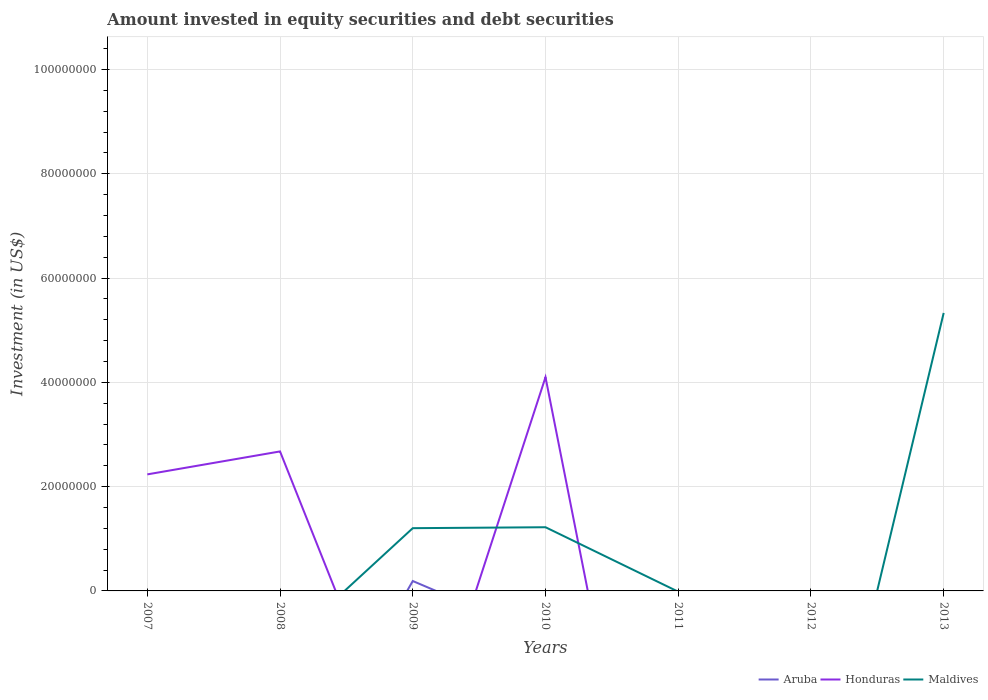How many different coloured lines are there?
Give a very brief answer. 3. Across all years, what is the maximum amount invested in equity securities and debt securities in Aruba?
Your response must be concise. 0. What is the difference between the highest and the second highest amount invested in equity securities and debt securities in Aruba?
Your answer should be compact. 1.90e+06. Are the values on the major ticks of Y-axis written in scientific E-notation?
Give a very brief answer. No. Does the graph contain grids?
Ensure brevity in your answer.  Yes. How many legend labels are there?
Your answer should be very brief. 3. What is the title of the graph?
Make the answer very short. Amount invested in equity securities and debt securities. Does "Bangladesh" appear as one of the legend labels in the graph?
Provide a succinct answer. No. What is the label or title of the Y-axis?
Offer a terse response. Investment (in US$). What is the Investment (in US$) of Aruba in 2007?
Offer a terse response. 0. What is the Investment (in US$) of Honduras in 2007?
Ensure brevity in your answer.  2.24e+07. What is the Investment (in US$) of Maldives in 2007?
Keep it short and to the point. 0. What is the Investment (in US$) of Honduras in 2008?
Your answer should be compact. 2.68e+07. What is the Investment (in US$) of Aruba in 2009?
Your response must be concise. 1.90e+06. What is the Investment (in US$) in Honduras in 2009?
Your answer should be compact. 0. What is the Investment (in US$) in Maldives in 2009?
Provide a short and direct response. 1.20e+07. What is the Investment (in US$) of Aruba in 2010?
Your answer should be very brief. 0. What is the Investment (in US$) of Honduras in 2010?
Make the answer very short. 4.10e+07. What is the Investment (in US$) in Maldives in 2010?
Ensure brevity in your answer.  1.22e+07. What is the Investment (in US$) of Aruba in 2012?
Keep it short and to the point. 0. What is the Investment (in US$) of Honduras in 2012?
Give a very brief answer. 0. What is the Investment (in US$) in Honduras in 2013?
Ensure brevity in your answer.  0. What is the Investment (in US$) of Maldives in 2013?
Provide a succinct answer. 5.33e+07. Across all years, what is the maximum Investment (in US$) in Aruba?
Your answer should be very brief. 1.90e+06. Across all years, what is the maximum Investment (in US$) in Honduras?
Offer a terse response. 4.10e+07. Across all years, what is the maximum Investment (in US$) in Maldives?
Ensure brevity in your answer.  5.33e+07. Across all years, what is the minimum Investment (in US$) in Maldives?
Your answer should be very brief. 0. What is the total Investment (in US$) of Aruba in the graph?
Provide a succinct answer. 1.90e+06. What is the total Investment (in US$) of Honduras in the graph?
Give a very brief answer. 9.01e+07. What is the total Investment (in US$) of Maldives in the graph?
Provide a succinct answer. 7.76e+07. What is the difference between the Investment (in US$) in Honduras in 2007 and that in 2008?
Provide a succinct answer. -4.40e+06. What is the difference between the Investment (in US$) in Honduras in 2007 and that in 2010?
Give a very brief answer. -1.86e+07. What is the difference between the Investment (in US$) in Honduras in 2008 and that in 2010?
Offer a terse response. -1.42e+07. What is the difference between the Investment (in US$) of Maldives in 2009 and that in 2010?
Offer a terse response. -1.81e+05. What is the difference between the Investment (in US$) of Maldives in 2009 and that in 2013?
Provide a short and direct response. -4.13e+07. What is the difference between the Investment (in US$) of Maldives in 2010 and that in 2013?
Your response must be concise. -4.11e+07. What is the difference between the Investment (in US$) in Honduras in 2007 and the Investment (in US$) in Maldives in 2009?
Offer a very short reply. 1.03e+07. What is the difference between the Investment (in US$) in Honduras in 2007 and the Investment (in US$) in Maldives in 2010?
Offer a terse response. 1.01e+07. What is the difference between the Investment (in US$) of Honduras in 2007 and the Investment (in US$) of Maldives in 2013?
Provide a succinct answer. -3.10e+07. What is the difference between the Investment (in US$) in Honduras in 2008 and the Investment (in US$) in Maldives in 2009?
Keep it short and to the point. 1.47e+07. What is the difference between the Investment (in US$) in Honduras in 2008 and the Investment (in US$) in Maldives in 2010?
Give a very brief answer. 1.45e+07. What is the difference between the Investment (in US$) in Honduras in 2008 and the Investment (in US$) in Maldives in 2013?
Ensure brevity in your answer.  -2.66e+07. What is the difference between the Investment (in US$) of Aruba in 2009 and the Investment (in US$) of Honduras in 2010?
Give a very brief answer. -3.91e+07. What is the difference between the Investment (in US$) of Aruba in 2009 and the Investment (in US$) of Maldives in 2010?
Ensure brevity in your answer.  -1.03e+07. What is the difference between the Investment (in US$) of Aruba in 2009 and the Investment (in US$) of Maldives in 2013?
Offer a terse response. -5.14e+07. What is the difference between the Investment (in US$) of Honduras in 2010 and the Investment (in US$) of Maldives in 2013?
Offer a terse response. -1.23e+07. What is the average Investment (in US$) in Aruba per year?
Give a very brief answer. 2.71e+05. What is the average Investment (in US$) of Honduras per year?
Ensure brevity in your answer.  1.29e+07. What is the average Investment (in US$) in Maldives per year?
Your response must be concise. 1.11e+07. In the year 2009, what is the difference between the Investment (in US$) in Aruba and Investment (in US$) in Maldives?
Your response must be concise. -1.01e+07. In the year 2010, what is the difference between the Investment (in US$) in Honduras and Investment (in US$) in Maldives?
Ensure brevity in your answer.  2.88e+07. What is the ratio of the Investment (in US$) in Honduras in 2007 to that in 2008?
Your answer should be very brief. 0.84. What is the ratio of the Investment (in US$) in Honduras in 2007 to that in 2010?
Offer a terse response. 0.55. What is the ratio of the Investment (in US$) of Honduras in 2008 to that in 2010?
Give a very brief answer. 0.65. What is the ratio of the Investment (in US$) in Maldives in 2009 to that in 2010?
Ensure brevity in your answer.  0.99. What is the ratio of the Investment (in US$) of Maldives in 2009 to that in 2013?
Keep it short and to the point. 0.23. What is the ratio of the Investment (in US$) of Maldives in 2010 to that in 2013?
Keep it short and to the point. 0.23. What is the difference between the highest and the second highest Investment (in US$) of Honduras?
Your response must be concise. 1.42e+07. What is the difference between the highest and the second highest Investment (in US$) in Maldives?
Offer a very short reply. 4.11e+07. What is the difference between the highest and the lowest Investment (in US$) of Aruba?
Your answer should be very brief. 1.90e+06. What is the difference between the highest and the lowest Investment (in US$) in Honduras?
Make the answer very short. 4.10e+07. What is the difference between the highest and the lowest Investment (in US$) in Maldives?
Offer a very short reply. 5.33e+07. 